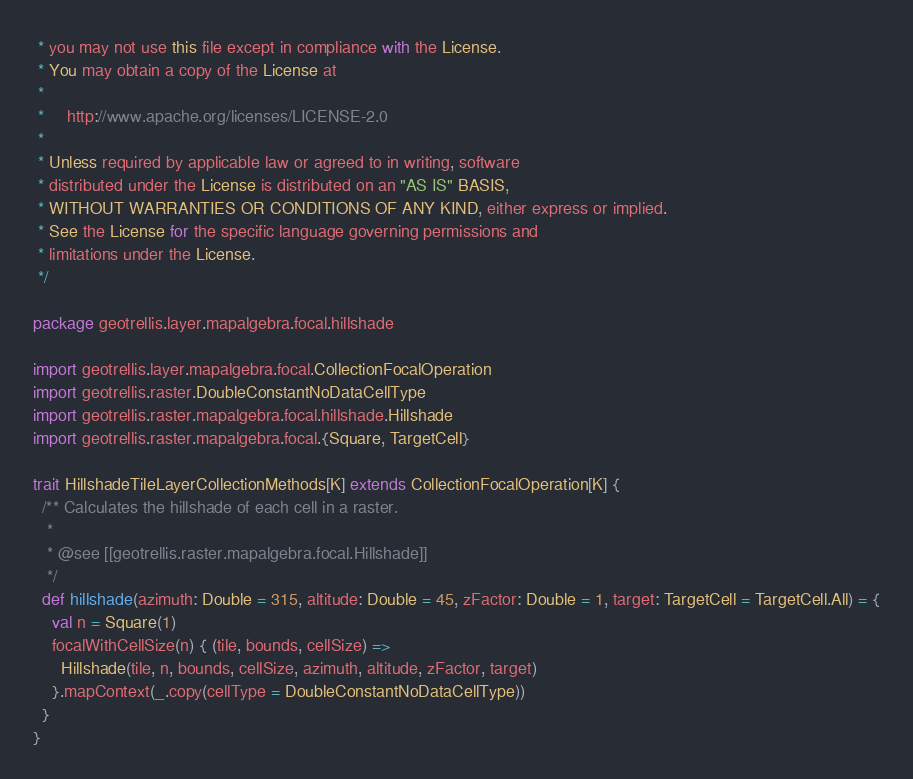Convert code to text. <code><loc_0><loc_0><loc_500><loc_500><_Scala_> * you may not use this file except in compliance with the License.
 * You may obtain a copy of the License at
 *
 *     http://www.apache.org/licenses/LICENSE-2.0
 *
 * Unless required by applicable law or agreed to in writing, software
 * distributed under the License is distributed on an "AS IS" BASIS,
 * WITHOUT WARRANTIES OR CONDITIONS OF ANY KIND, either express or implied.
 * See the License for the specific language governing permissions and
 * limitations under the License.
 */

package geotrellis.layer.mapalgebra.focal.hillshade

import geotrellis.layer.mapalgebra.focal.CollectionFocalOperation
import geotrellis.raster.DoubleConstantNoDataCellType
import geotrellis.raster.mapalgebra.focal.hillshade.Hillshade
import geotrellis.raster.mapalgebra.focal.{Square, TargetCell}

trait HillshadeTileLayerCollectionMethods[K] extends CollectionFocalOperation[K] {
  /** Calculates the hillshade of each cell in a raster.
   *
   * @see [[geotrellis.raster.mapalgebra.focal.Hillshade]]
   */
  def hillshade(azimuth: Double = 315, altitude: Double = 45, zFactor: Double = 1, target: TargetCell = TargetCell.All) = {
    val n = Square(1)
    focalWithCellSize(n) { (tile, bounds, cellSize) =>
      Hillshade(tile, n, bounds, cellSize, azimuth, altitude, zFactor, target)
    }.mapContext(_.copy(cellType = DoubleConstantNoDataCellType))
  }
}
</code> 